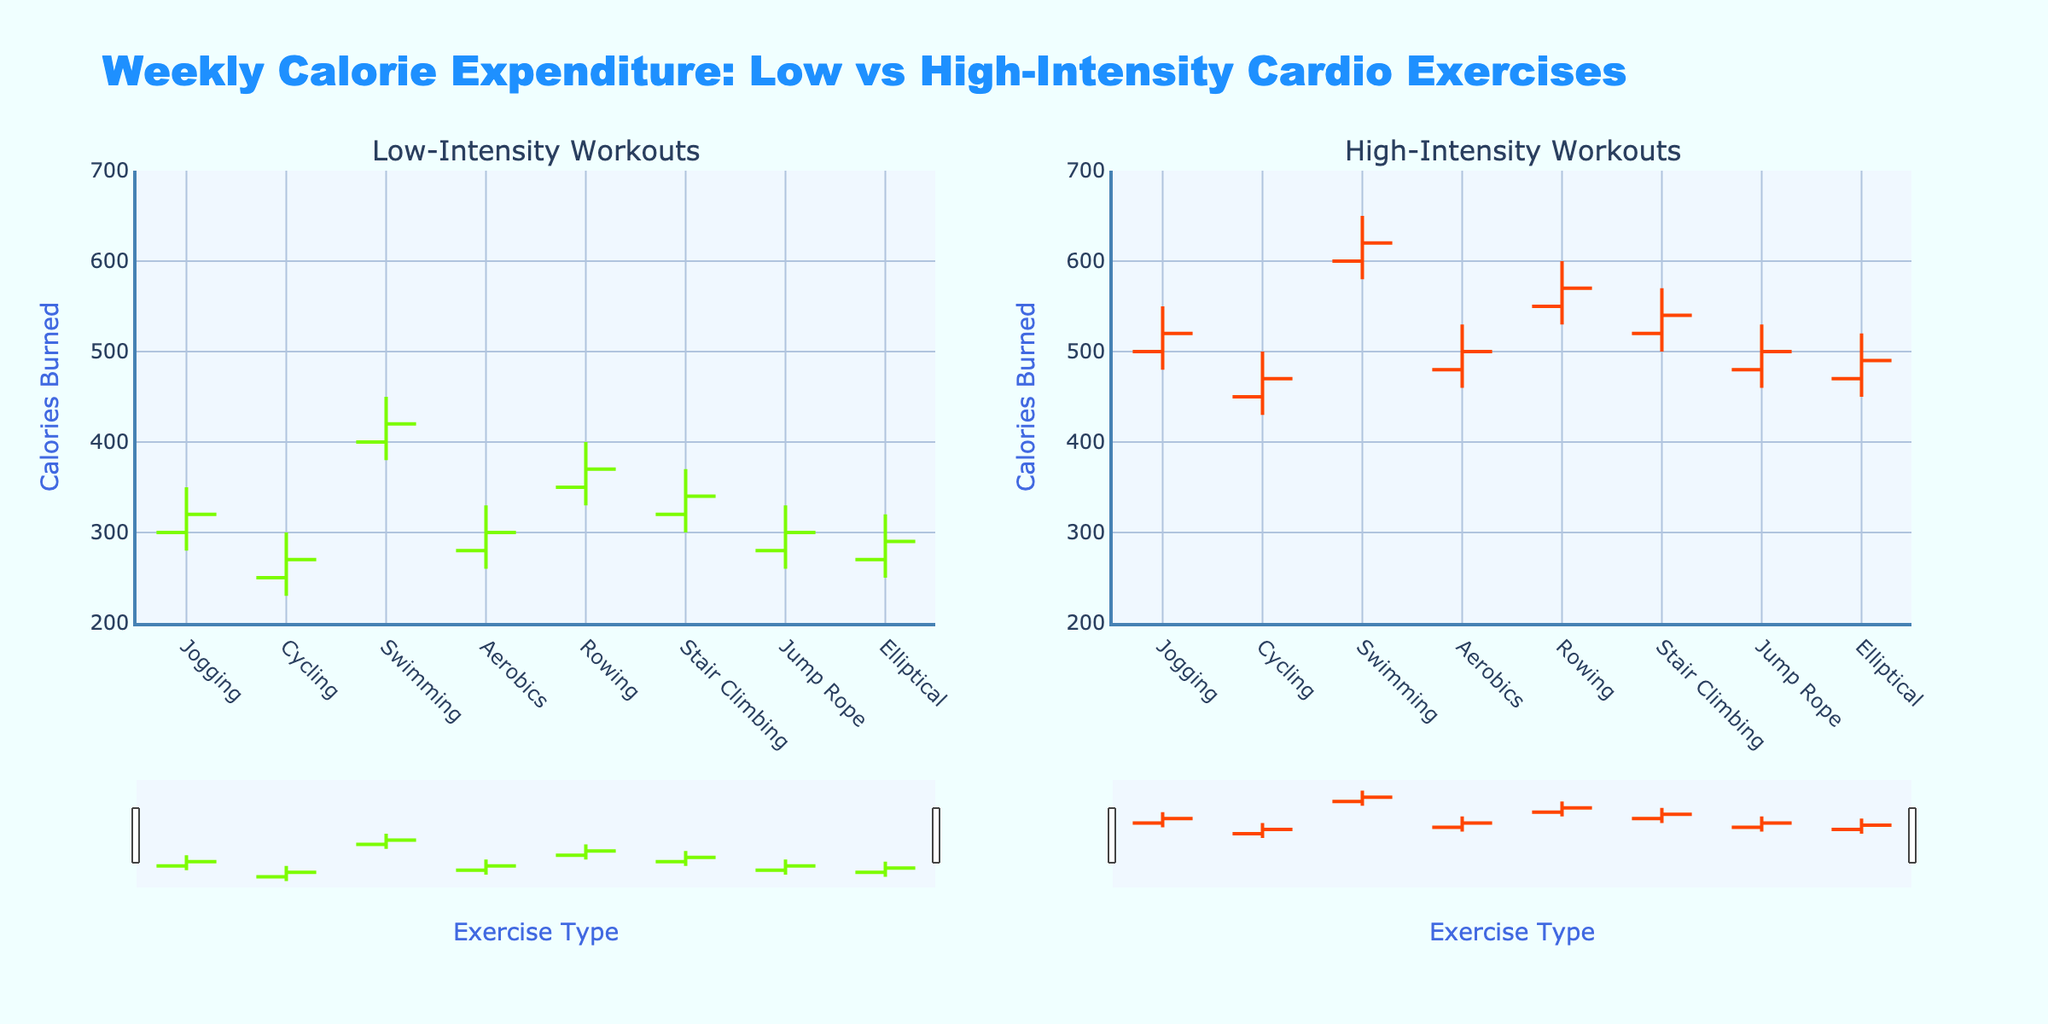What's the title of the figure? The title of the figure is displayed at the top, helping to understand the overall context of the chart.
Answer: Weekly Calorie Expenditure: Low vs High-Intensity Cardio Exercises How many types of exercises are compared in the figure? The number of types of exercises can be counted from the x-axis labels, which list each unique exercise.
Answer: 8 What is the highest calorie value for low-intensity jogging? Look at the OHLC data for jogging under the low-intensity subplot and identify the highest value in the high column.
Answer: 350 Which exercise has the highest close value in high-intensity workouts? Compare the close values across all exercises in the high-intensity subplot and identify the highest one.
Answer: Swimming For high-intensity cycling, what's the difference between the high and low calorie values? Subtract the low value from the high value for high-intensity cycling, viewed in the appropriate subplot.
Answer: 70 In low-intensity workouts, which exercise shows the greatest range in calorie expenditure? For each exercise in the low-intensity subplot, calculate the range (high - low) and find the maximum range.
Answer: Jogging and Swimming Compare the close values of high-intensity and low-intensity rowing. Which one is higher? Compare the close values of rowing in both subplots to see which one is greater.
Answer: High-Intensity Are there any exercises where the low-intensity close value is greater than the high-intensity open value? Check each exercise to see if the close value in the low-intensity subplot is greater than the open value in the high-intensity subplot.
Answer: No 